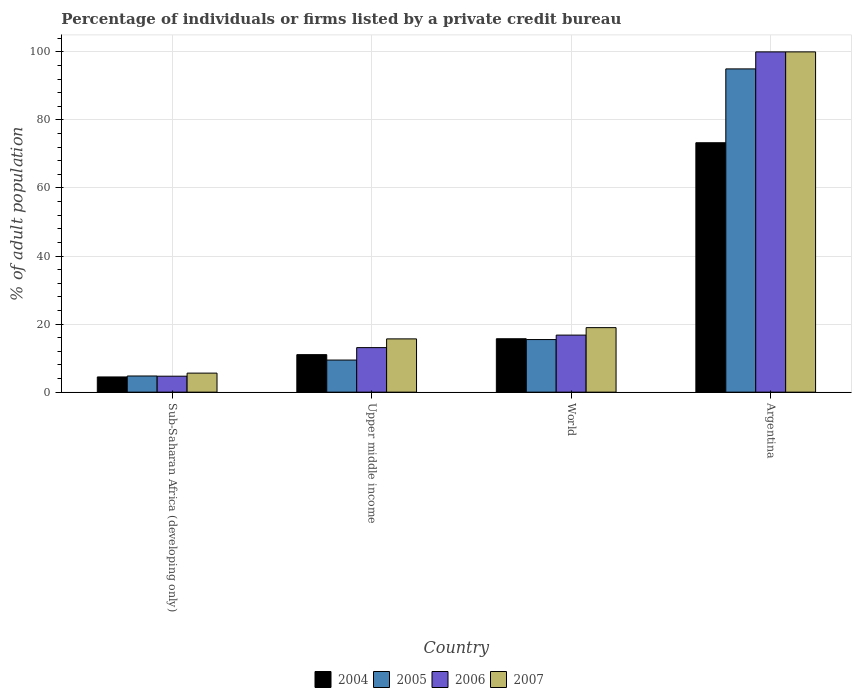How many different coloured bars are there?
Ensure brevity in your answer.  4. How many groups of bars are there?
Make the answer very short. 4. Are the number of bars per tick equal to the number of legend labels?
Your answer should be very brief. Yes. How many bars are there on the 1st tick from the right?
Your response must be concise. 4. What is the label of the 2nd group of bars from the left?
Ensure brevity in your answer.  Upper middle income. What is the percentage of population listed by a private credit bureau in 2004 in Sub-Saharan Africa (developing only)?
Your answer should be compact. 4.47. Across all countries, what is the maximum percentage of population listed by a private credit bureau in 2007?
Ensure brevity in your answer.  100. Across all countries, what is the minimum percentage of population listed by a private credit bureau in 2006?
Your answer should be very brief. 4.69. In which country was the percentage of population listed by a private credit bureau in 2005 maximum?
Your answer should be very brief. Argentina. In which country was the percentage of population listed by a private credit bureau in 2005 minimum?
Your response must be concise. Sub-Saharan Africa (developing only). What is the total percentage of population listed by a private credit bureau in 2007 in the graph?
Offer a terse response. 140.2. What is the difference between the percentage of population listed by a private credit bureau in 2007 in Sub-Saharan Africa (developing only) and that in World?
Provide a short and direct response. -13.37. What is the difference between the percentage of population listed by a private credit bureau in 2005 in Argentina and the percentage of population listed by a private credit bureau in 2007 in World?
Make the answer very short. 76.04. What is the average percentage of population listed by a private credit bureau in 2006 per country?
Your response must be concise. 33.64. What is the difference between the percentage of population listed by a private credit bureau of/in 2006 and percentage of population listed by a private credit bureau of/in 2007 in Sub-Saharan Africa (developing only)?
Offer a terse response. -0.9. What is the ratio of the percentage of population listed by a private credit bureau in 2005 in Upper middle income to that in World?
Give a very brief answer. 0.61. Is the percentage of population listed by a private credit bureau in 2004 in Argentina less than that in World?
Your answer should be compact. No. Is the difference between the percentage of population listed by a private credit bureau in 2006 in Argentina and World greater than the difference between the percentage of population listed by a private credit bureau in 2007 in Argentina and World?
Offer a very short reply. Yes. What is the difference between the highest and the second highest percentage of population listed by a private credit bureau in 2006?
Provide a short and direct response. -83.23. What is the difference between the highest and the lowest percentage of population listed by a private credit bureau in 2007?
Give a very brief answer. 94.41. In how many countries, is the percentage of population listed by a private credit bureau in 2004 greater than the average percentage of population listed by a private credit bureau in 2004 taken over all countries?
Give a very brief answer. 1. What does the 2nd bar from the right in Argentina represents?
Offer a very short reply. 2006. How many countries are there in the graph?
Your response must be concise. 4. Are the values on the major ticks of Y-axis written in scientific E-notation?
Provide a short and direct response. No. Does the graph contain any zero values?
Offer a terse response. No. How many legend labels are there?
Make the answer very short. 4. How are the legend labels stacked?
Your answer should be very brief. Horizontal. What is the title of the graph?
Give a very brief answer. Percentage of individuals or firms listed by a private credit bureau. Does "1988" appear as one of the legend labels in the graph?
Make the answer very short. No. What is the label or title of the Y-axis?
Make the answer very short. % of adult population. What is the % of adult population in 2004 in Sub-Saharan Africa (developing only)?
Ensure brevity in your answer.  4.47. What is the % of adult population of 2005 in Sub-Saharan Africa (developing only)?
Offer a terse response. 4.75. What is the % of adult population of 2006 in Sub-Saharan Africa (developing only)?
Ensure brevity in your answer.  4.69. What is the % of adult population in 2007 in Sub-Saharan Africa (developing only)?
Your response must be concise. 5.59. What is the % of adult population in 2004 in Upper middle income?
Your answer should be compact. 11.02. What is the % of adult population of 2005 in Upper middle income?
Your answer should be compact. 9.43. What is the % of adult population in 2006 in Upper middle income?
Provide a short and direct response. 13.09. What is the % of adult population of 2007 in Upper middle income?
Your response must be concise. 15.65. What is the % of adult population of 2004 in World?
Your answer should be very brief. 15.7. What is the % of adult population in 2005 in World?
Provide a short and direct response. 15.46. What is the % of adult population of 2006 in World?
Your answer should be compact. 16.77. What is the % of adult population in 2007 in World?
Ensure brevity in your answer.  18.96. What is the % of adult population of 2004 in Argentina?
Offer a very short reply. 73.3. Across all countries, what is the maximum % of adult population of 2004?
Your response must be concise. 73.3. Across all countries, what is the maximum % of adult population in 2005?
Provide a succinct answer. 95. Across all countries, what is the minimum % of adult population of 2004?
Provide a short and direct response. 4.47. Across all countries, what is the minimum % of adult population in 2005?
Keep it short and to the point. 4.75. Across all countries, what is the minimum % of adult population of 2006?
Offer a very short reply. 4.69. Across all countries, what is the minimum % of adult population in 2007?
Make the answer very short. 5.59. What is the total % of adult population of 2004 in the graph?
Your answer should be compact. 104.49. What is the total % of adult population of 2005 in the graph?
Give a very brief answer. 124.64. What is the total % of adult population of 2006 in the graph?
Keep it short and to the point. 134.54. What is the total % of adult population of 2007 in the graph?
Keep it short and to the point. 140.2. What is the difference between the % of adult population of 2004 in Sub-Saharan Africa (developing only) and that in Upper middle income?
Make the answer very short. -6.55. What is the difference between the % of adult population of 2005 in Sub-Saharan Africa (developing only) and that in Upper middle income?
Your answer should be very brief. -4.68. What is the difference between the % of adult population of 2006 in Sub-Saharan Africa (developing only) and that in Upper middle income?
Your answer should be compact. -8.4. What is the difference between the % of adult population in 2007 in Sub-Saharan Africa (developing only) and that in Upper middle income?
Keep it short and to the point. -10.06. What is the difference between the % of adult population in 2004 in Sub-Saharan Africa (developing only) and that in World?
Give a very brief answer. -11.23. What is the difference between the % of adult population in 2005 in Sub-Saharan Africa (developing only) and that in World?
Offer a very short reply. -10.71. What is the difference between the % of adult population in 2006 in Sub-Saharan Africa (developing only) and that in World?
Provide a short and direct response. -12.08. What is the difference between the % of adult population of 2007 in Sub-Saharan Africa (developing only) and that in World?
Provide a succinct answer. -13.37. What is the difference between the % of adult population of 2004 in Sub-Saharan Africa (developing only) and that in Argentina?
Provide a succinct answer. -68.83. What is the difference between the % of adult population of 2005 in Sub-Saharan Africa (developing only) and that in Argentina?
Ensure brevity in your answer.  -90.25. What is the difference between the % of adult population in 2006 in Sub-Saharan Africa (developing only) and that in Argentina?
Offer a very short reply. -95.31. What is the difference between the % of adult population in 2007 in Sub-Saharan Africa (developing only) and that in Argentina?
Your response must be concise. -94.41. What is the difference between the % of adult population in 2004 in Upper middle income and that in World?
Provide a succinct answer. -4.67. What is the difference between the % of adult population of 2005 in Upper middle income and that in World?
Provide a succinct answer. -6.02. What is the difference between the % of adult population of 2006 in Upper middle income and that in World?
Your answer should be very brief. -3.68. What is the difference between the % of adult population in 2007 in Upper middle income and that in World?
Keep it short and to the point. -3.31. What is the difference between the % of adult population in 2004 in Upper middle income and that in Argentina?
Keep it short and to the point. -62.28. What is the difference between the % of adult population in 2005 in Upper middle income and that in Argentina?
Make the answer very short. -85.57. What is the difference between the % of adult population in 2006 in Upper middle income and that in Argentina?
Keep it short and to the point. -86.91. What is the difference between the % of adult population in 2007 in Upper middle income and that in Argentina?
Your answer should be very brief. -84.35. What is the difference between the % of adult population of 2004 in World and that in Argentina?
Provide a short and direct response. -57.6. What is the difference between the % of adult population of 2005 in World and that in Argentina?
Your answer should be compact. -79.54. What is the difference between the % of adult population in 2006 in World and that in Argentina?
Your answer should be very brief. -83.23. What is the difference between the % of adult population in 2007 in World and that in Argentina?
Your response must be concise. -81.04. What is the difference between the % of adult population in 2004 in Sub-Saharan Africa (developing only) and the % of adult population in 2005 in Upper middle income?
Ensure brevity in your answer.  -4.96. What is the difference between the % of adult population in 2004 in Sub-Saharan Africa (developing only) and the % of adult population in 2006 in Upper middle income?
Your answer should be compact. -8.62. What is the difference between the % of adult population of 2004 in Sub-Saharan Africa (developing only) and the % of adult population of 2007 in Upper middle income?
Your answer should be compact. -11.18. What is the difference between the % of adult population in 2005 in Sub-Saharan Africa (developing only) and the % of adult population in 2006 in Upper middle income?
Ensure brevity in your answer.  -8.34. What is the difference between the % of adult population of 2005 in Sub-Saharan Africa (developing only) and the % of adult population of 2007 in Upper middle income?
Offer a very short reply. -10.9. What is the difference between the % of adult population of 2006 in Sub-Saharan Africa (developing only) and the % of adult population of 2007 in Upper middle income?
Your response must be concise. -10.97. What is the difference between the % of adult population in 2004 in Sub-Saharan Africa (developing only) and the % of adult population in 2005 in World?
Give a very brief answer. -10.99. What is the difference between the % of adult population of 2004 in Sub-Saharan Africa (developing only) and the % of adult population of 2006 in World?
Offer a very short reply. -12.3. What is the difference between the % of adult population in 2004 in Sub-Saharan Africa (developing only) and the % of adult population in 2007 in World?
Ensure brevity in your answer.  -14.49. What is the difference between the % of adult population of 2005 in Sub-Saharan Africa (developing only) and the % of adult population of 2006 in World?
Offer a very short reply. -12.02. What is the difference between the % of adult population of 2005 in Sub-Saharan Africa (developing only) and the % of adult population of 2007 in World?
Provide a short and direct response. -14.21. What is the difference between the % of adult population in 2006 in Sub-Saharan Africa (developing only) and the % of adult population in 2007 in World?
Provide a short and direct response. -14.27. What is the difference between the % of adult population of 2004 in Sub-Saharan Africa (developing only) and the % of adult population of 2005 in Argentina?
Make the answer very short. -90.53. What is the difference between the % of adult population in 2004 in Sub-Saharan Africa (developing only) and the % of adult population in 2006 in Argentina?
Offer a very short reply. -95.53. What is the difference between the % of adult population in 2004 in Sub-Saharan Africa (developing only) and the % of adult population in 2007 in Argentina?
Provide a succinct answer. -95.53. What is the difference between the % of adult population in 2005 in Sub-Saharan Africa (developing only) and the % of adult population in 2006 in Argentina?
Offer a very short reply. -95.25. What is the difference between the % of adult population of 2005 in Sub-Saharan Africa (developing only) and the % of adult population of 2007 in Argentina?
Offer a terse response. -95.25. What is the difference between the % of adult population of 2006 in Sub-Saharan Africa (developing only) and the % of adult population of 2007 in Argentina?
Ensure brevity in your answer.  -95.31. What is the difference between the % of adult population of 2004 in Upper middle income and the % of adult population of 2005 in World?
Offer a terse response. -4.43. What is the difference between the % of adult population in 2004 in Upper middle income and the % of adult population in 2006 in World?
Offer a terse response. -5.74. What is the difference between the % of adult population in 2004 in Upper middle income and the % of adult population in 2007 in World?
Provide a short and direct response. -7.94. What is the difference between the % of adult population in 2005 in Upper middle income and the % of adult population in 2006 in World?
Make the answer very short. -7.33. What is the difference between the % of adult population in 2005 in Upper middle income and the % of adult population in 2007 in World?
Provide a succinct answer. -9.53. What is the difference between the % of adult population in 2006 in Upper middle income and the % of adult population in 2007 in World?
Provide a succinct answer. -5.87. What is the difference between the % of adult population in 2004 in Upper middle income and the % of adult population in 2005 in Argentina?
Provide a succinct answer. -83.98. What is the difference between the % of adult population in 2004 in Upper middle income and the % of adult population in 2006 in Argentina?
Your answer should be very brief. -88.98. What is the difference between the % of adult population of 2004 in Upper middle income and the % of adult population of 2007 in Argentina?
Your response must be concise. -88.98. What is the difference between the % of adult population of 2005 in Upper middle income and the % of adult population of 2006 in Argentina?
Your answer should be compact. -90.57. What is the difference between the % of adult population in 2005 in Upper middle income and the % of adult population in 2007 in Argentina?
Keep it short and to the point. -90.57. What is the difference between the % of adult population in 2006 in Upper middle income and the % of adult population in 2007 in Argentina?
Offer a terse response. -86.91. What is the difference between the % of adult population of 2004 in World and the % of adult population of 2005 in Argentina?
Offer a very short reply. -79.3. What is the difference between the % of adult population of 2004 in World and the % of adult population of 2006 in Argentina?
Provide a short and direct response. -84.3. What is the difference between the % of adult population of 2004 in World and the % of adult population of 2007 in Argentina?
Offer a very short reply. -84.3. What is the difference between the % of adult population in 2005 in World and the % of adult population in 2006 in Argentina?
Offer a very short reply. -84.54. What is the difference between the % of adult population in 2005 in World and the % of adult population in 2007 in Argentina?
Keep it short and to the point. -84.54. What is the difference between the % of adult population in 2006 in World and the % of adult population in 2007 in Argentina?
Provide a succinct answer. -83.23. What is the average % of adult population in 2004 per country?
Keep it short and to the point. 26.12. What is the average % of adult population in 2005 per country?
Ensure brevity in your answer.  31.16. What is the average % of adult population in 2006 per country?
Offer a terse response. 33.64. What is the average % of adult population in 2007 per country?
Your response must be concise. 35.05. What is the difference between the % of adult population in 2004 and % of adult population in 2005 in Sub-Saharan Africa (developing only)?
Provide a succinct answer. -0.28. What is the difference between the % of adult population of 2004 and % of adult population of 2006 in Sub-Saharan Africa (developing only)?
Your answer should be compact. -0.22. What is the difference between the % of adult population in 2004 and % of adult population in 2007 in Sub-Saharan Africa (developing only)?
Your response must be concise. -1.12. What is the difference between the % of adult population of 2005 and % of adult population of 2006 in Sub-Saharan Africa (developing only)?
Provide a short and direct response. 0.06. What is the difference between the % of adult population in 2005 and % of adult population in 2007 in Sub-Saharan Africa (developing only)?
Ensure brevity in your answer.  -0.84. What is the difference between the % of adult population in 2006 and % of adult population in 2007 in Sub-Saharan Africa (developing only)?
Your answer should be compact. -0.9. What is the difference between the % of adult population in 2004 and % of adult population in 2005 in Upper middle income?
Provide a short and direct response. 1.59. What is the difference between the % of adult population of 2004 and % of adult population of 2006 in Upper middle income?
Give a very brief answer. -2.07. What is the difference between the % of adult population of 2004 and % of adult population of 2007 in Upper middle income?
Offer a very short reply. -4.63. What is the difference between the % of adult population of 2005 and % of adult population of 2006 in Upper middle income?
Your answer should be very brief. -3.66. What is the difference between the % of adult population of 2005 and % of adult population of 2007 in Upper middle income?
Provide a short and direct response. -6.22. What is the difference between the % of adult population in 2006 and % of adult population in 2007 in Upper middle income?
Provide a succinct answer. -2.56. What is the difference between the % of adult population of 2004 and % of adult population of 2005 in World?
Ensure brevity in your answer.  0.24. What is the difference between the % of adult population of 2004 and % of adult population of 2006 in World?
Make the answer very short. -1.07. What is the difference between the % of adult population in 2004 and % of adult population in 2007 in World?
Give a very brief answer. -3.26. What is the difference between the % of adult population of 2005 and % of adult population of 2006 in World?
Your answer should be very brief. -1.31. What is the difference between the % of adult population in 2005 and % of adult population in 2007 in World?
Your answer should be compact. -3.5. What is the difference between the % of adult population in 2006 and % of adult population in 2007 in World?
Offer a very short reply. -2.19. What is the difference between the % of adult population in 2004 and % of adult population in 2005 in Argentina?
Keep it short and to the point. -21.7. What is the difference between the % of adult population of 2004 and % of adult population of 2006 in Argentina?
Your answer should be very brief. -26.7. What is the difference between the % of adult population in 2004 and % of adult population in 2007 in Argentina?
Provide a succinct answer. -26.7. What is the difference between the % of adult population in 2005 and % of adult population in 2006 in Argentina?
Ensure brevity in your answer.  -5. What is the difference between the % of adult population in 2005 and % of adult population in 2007 in Argentina?
Your response must be concise. -5. What is the difference between the % of adult population of 2006 and % of adult population of 2007 in Argentina?
Your answer should be compact. 0. What is the ratio of the % of adult population of 2004 in Sub-Saharan Africa (developing only) to that in Upper middle income?
Provide a succinct answer. 0.41. What is the ratio of the % of adult population of 2005 in Sub-Saharan Africa (developing only) to that in Upper middle income?
Give a very brief answer. 0.5. What is the ratio of the % of adult population of 2006 in Sub-Saharan Africa (developing only) to that in Upper middle income?
Keep it short and to the point. 0.36. What is the ratio of the % of adult population of 2007 in Sub-Saharan Africa (developing only) to that in Upper middle income?
Your response must be concise. 0.36. What is the ratio of the % of adult population in 2004 in Sub-Saharan Africa (developing only) to that in World?
Offer a terse response. 0.28. What is the ratio of the % of adult population of 2005 in Sub-Saharan Africa (developing only) to that in World?
Your response must be concise. 0.31. What is the ratio of the % of adult population of 2006 in Sub-Saharan Africa (developing only) to that in World?
Provide a short and direct response. 0.28. What is the ratio of the % of adult population of 2007 in Sub-Saharan Africa (developing only) to that in World?
Your response must be concise. 0.29. What is the ratio of the % of adult population in 2004 in Sub-Saharan Africa (developing only) to that in Argentina?
Provide a short and direct response. 0.06. What is the ratio of the % of adult population in 2006 in Sub-Saharan Africa (developing only) to that in Argentina?
Ensure brevity in your answer.  0.05. What is the ratio of the % of adult population in 2007 in Sub-Saharan Africa (developing only) to that in Argentina?
Provide a short and direct response. 0.06. What is the ratio of the % of adult population of 2004 in Upper middle income to that in World?
Make the answer very short. 0.7. What is the ratio of the % of adult population of 2005 in Upper middle income to that in World?
Offer a very short reply. 0.61. What is the ratio of the % of adult population in 2006 in Upper middle income to that in World?
Provide a short and direct response. 0.78. What is the ratio of the % of adult population in 2007 in Upper middle income to that in World?
Your answer should be very brief. 0.83. What is the ratio of the % of adult population of 2004 in Upper middle income to that in Argentina?
Give a very brief answer. 0.15. What is the ratio of the % of adult population in 2005 in Upper middle income to that in Argentina?
Keep it short and to the point. 0.1. What is the ratio of the % of adult population in 2006 in Upper middle income to that in Argentina?
Offer a terse response. 0.13. What is the ratio of the % of adult population in 2007 in Upper middle income to that in Argentina?
Keep it short and to the point. 0.16. What is the ratio of the % of adult population in 2004 in World to that in Argentina?
Offer a very short reply. 0.21. What is the ratio of the % of adult population in 2005 in World to that in Argentina?
Offer a very short reply. 0.16. What is the ratio of the % of adult population in 2006 in World to that in Argentina?
Your response must be concise. 0.17. What is the ratio of the % of adult population of 2007 in World to that in Argentina?
Make the answer very short. 0.19. What is the difference between the highest and the second highest % of adult population of 2004?
Make the answer very short. 57.6. What is the difference between the highest and the second highest % of adult population of 2005?
Provide a succinct answer. 79.54. What is the difference between the highest and the second highest % of adult population in 2006?
Your response must be concise. 83.23. What is the difference between the highest and the second highest % of adult population in 2007?
Ensure brevity in your answer.  81.04. What is the difference between the highest and the lowest % of adult population of 2004?
Ensure brevity in your answer.  68.83. What is the difference between the highest and the lowest % of adult population in 2005?
Provide a succinct answer. 90.25. What is the difference between the highest and the lowest % of adult population of 2006?
Your answer should be very brief. 95.31. What is the difference between the highest and the lowest % of adult population in 2007?
Ensure brevity in your answer.  94.41. 